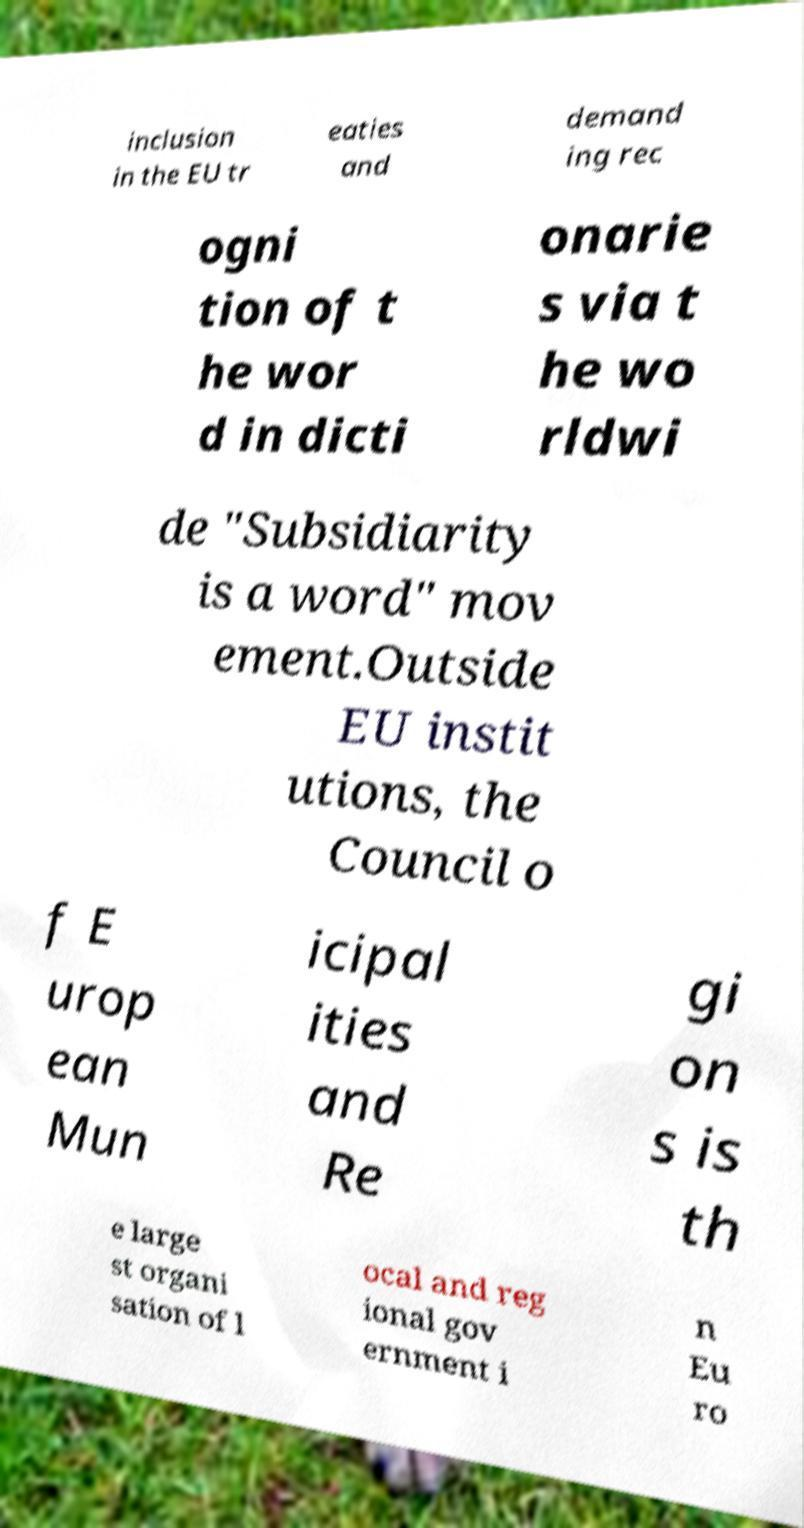I need the written content from this picture converted into text. Can you do that? inclusion in the EU tr eaties and demand ing rec ogni tion of t he wor d in dicti onarie s via t he wo rldwi de "Subsidiarity is a word" mov ement.Outside EU instit utions, the Council o f E urop ean Mun icipal ities and Re gi on s is th e large st organi sation of l ocal and reg ional gov ernment i n Eu ro 